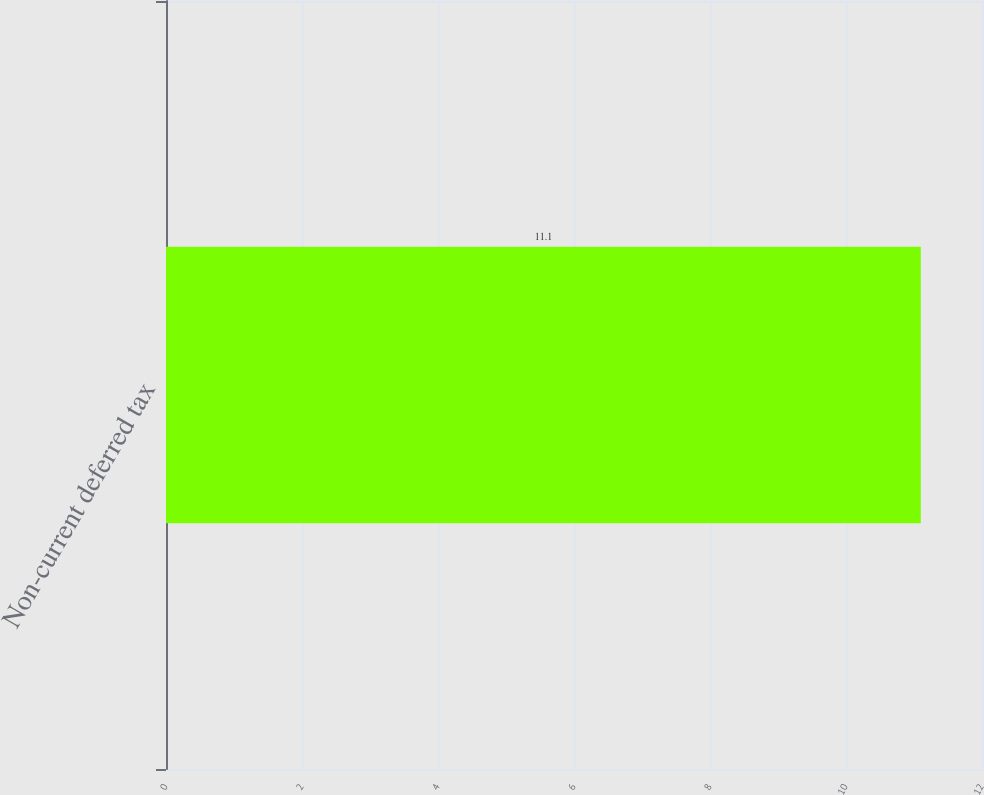Convert chart. <chart><loc_0><loc_0><loc_500><loc_500><bar_chart><fcel>Non-current deferred tax<nl><fcel>11.1<nl></chart> 